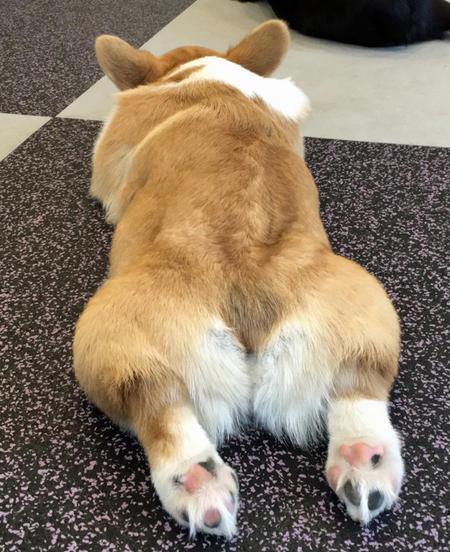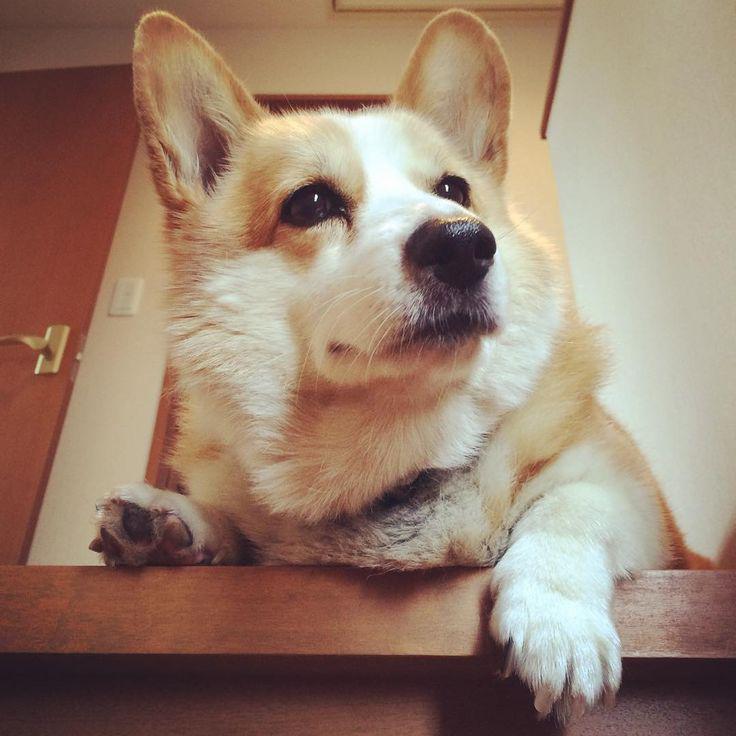The first image is the image on the left, the second image is the image on the right. Considering the images on both sides, is "One image contains one orange-and-white corgi posed on its belly with its rear toward the camera." valid? Answer yes or no. Yes. The first image is the image on the left, the second image is the image on the right. For the images displayed, is the sentence "There is at least four dogs in the left image." factually correct? Answer yes or no. No. 